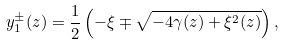<formula> <loc_0><loc_0><loc_500><loc_500>y _ { 1 } ^ { \pm } ( z ) = \frac { 1 } { 2 } \left ( - \xi \mp \sqrt { - 4 \gamma ( z ) + \xi ^ { 2 } ( z ) } \right ) ,</formula> 